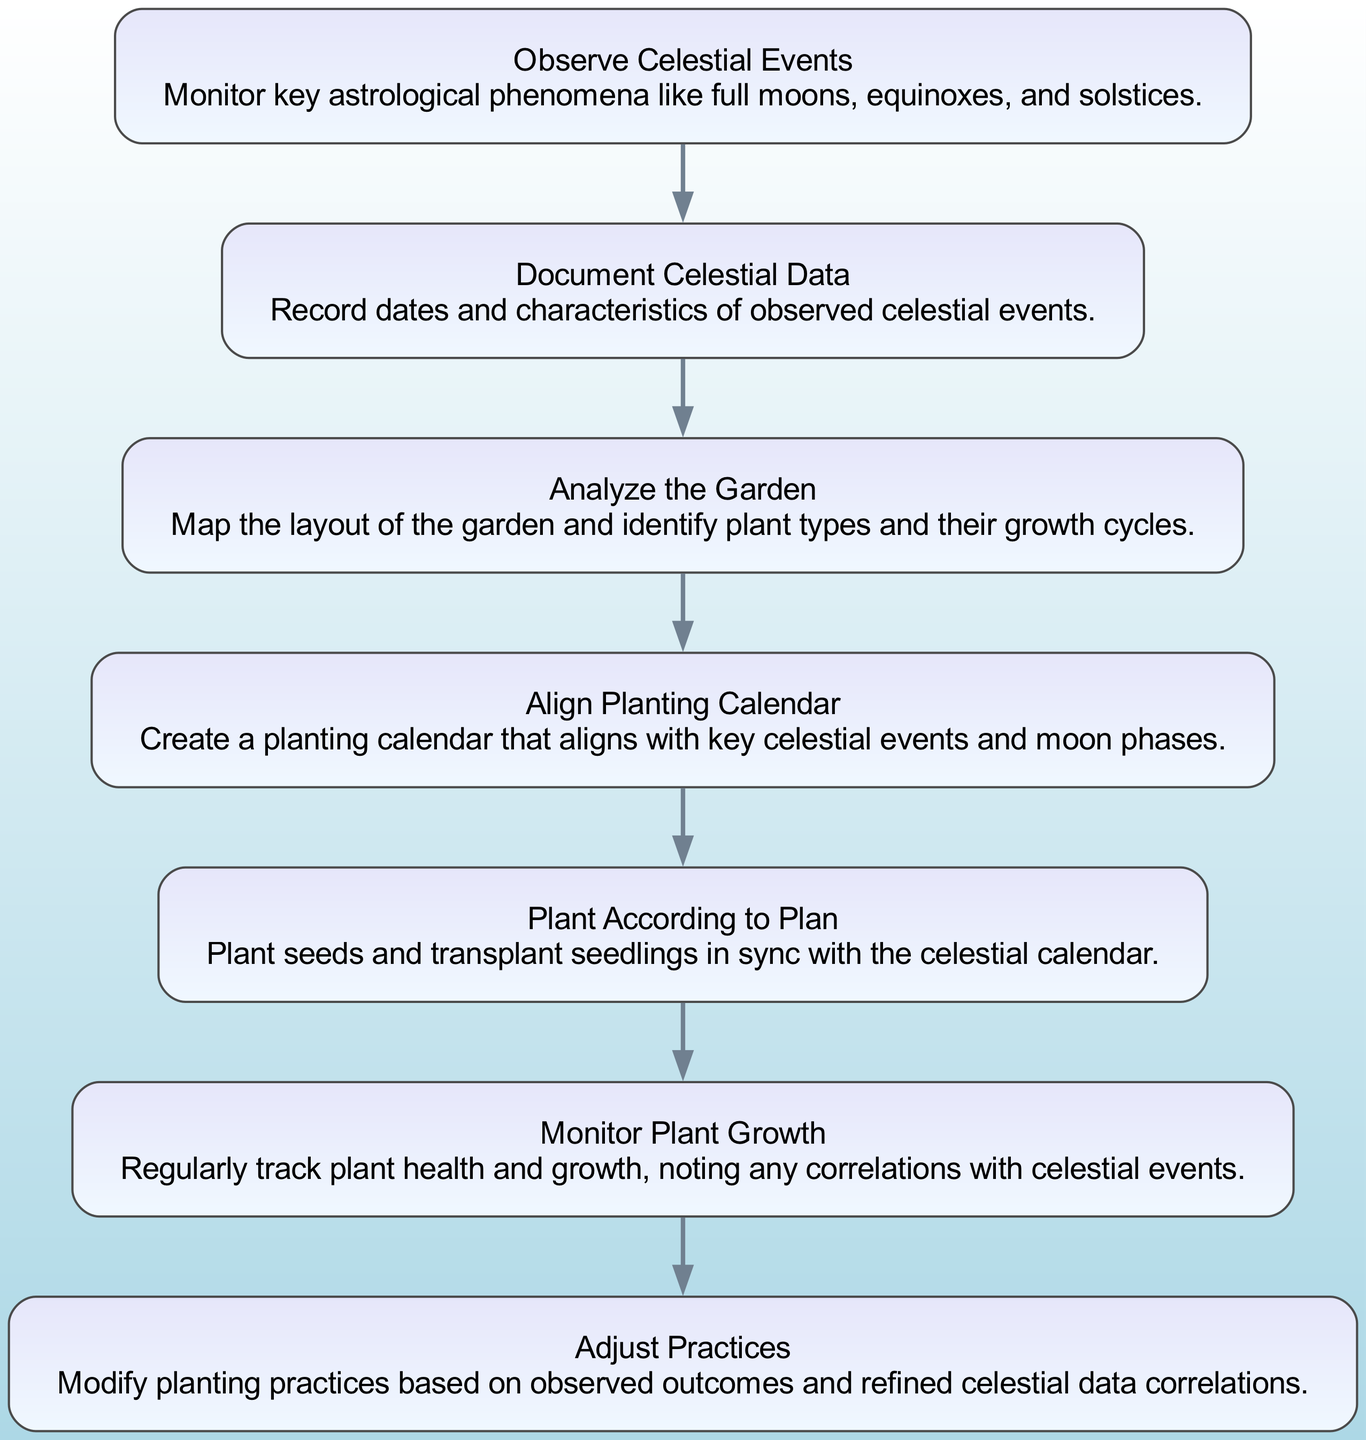What is the first step in the diagram? The diagram starts with the first element labeled "Observe Celestial Events." This is explicitly stated as the initial action in the flow chart.
Answer: Observe Celestial Events How many total nodes are in the diagram? The diagram contains 7 nodes which correspond to each step in the process outlined in the data under "elements."
Answer: 7 What is the last step in the flow chart? The final element in the diagram is "Adjust Practices," which is indicated as the last node in the sequence with no next node following it.
Answer: Adjust Practices Which node follows "Analyze the Garden"? The next node after "Analyze the Garden" is "Align Planting Calendar." This is inferred from the directed connection line shown in the flow chart.
Answer: Align Planting Calendar What do you need to create after documenting celestial data? After documenting celestial data, the next action required is to "Analyze the Garden." This sequential flow is indicated by the arrow leading to the next node.
Answer: Analyze the Garden How does "Monitor Plant Growth" relate to "Adjust Practices"? "Monitor Plant Growth" directly leads to "Adjust Practices" in the flow chart, indicating that observations from monitoring plant growth are used to inform adjustments in practices.
Answer: Directly leads to What is the relationship between "Plant According to Plan" and "Monitor Plant Growth"? "Plant According to Plan" precedes "Monitor Plant Growth," suggesting that planting must occur before monitoring can take place, reflecting a logical sequence in the gardening process.
Answer: Precedes Which step has the most detailed description? The node "Align Planting Calendar" provides a detailed description of creating a calendar that aligns with celestial events and moon phases, providing specific context to the planting schedule.
Answer: Align Planting Calendar How many steps are needed to complete the process from the beginning to the end? The process flows through 7 distinct steps from "Observe Celestial Events" to "Adjust Practices," representing a linear progression through the activities outlined in the garden mapping.
Answer: 7 